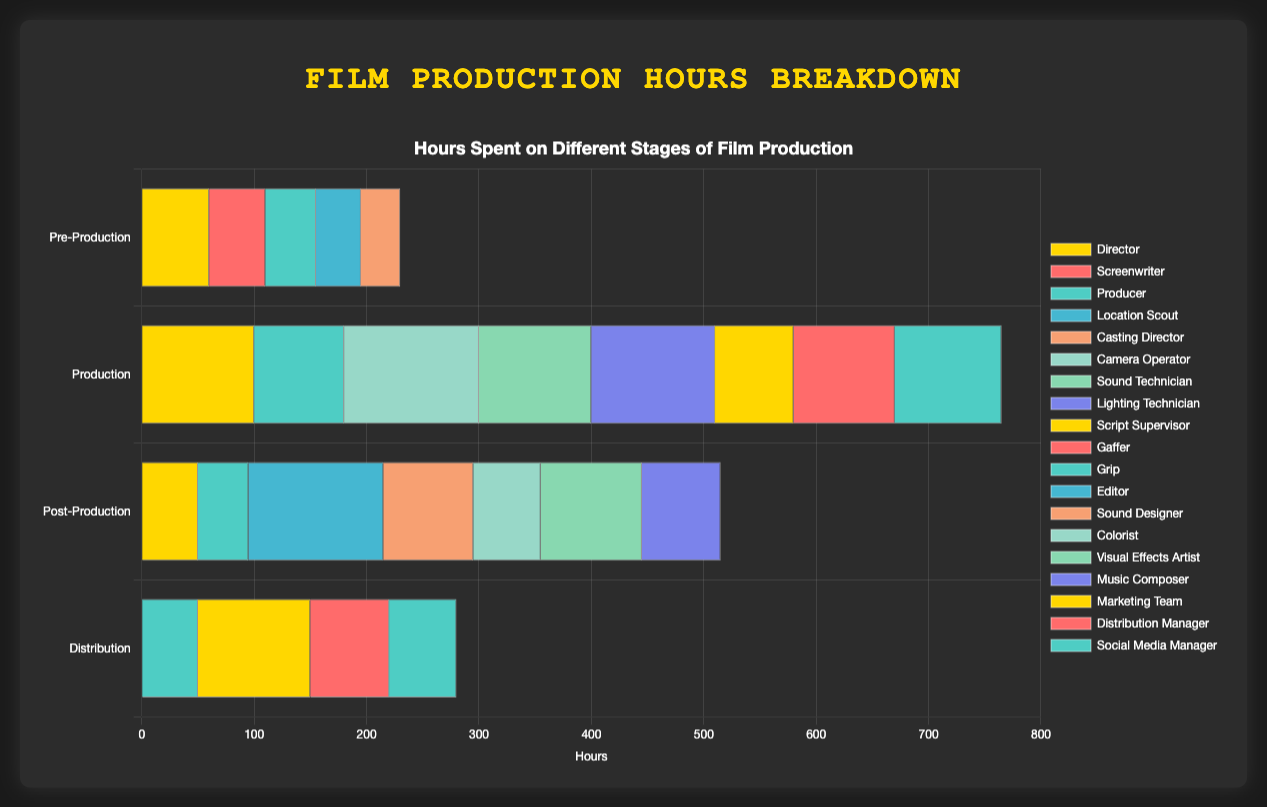Which stage required the most hours for the Director role? The figure shows a horizontal grouped bar chart, where the Director's role is consistently represented with a specific color across all stages. Comparing the lengths of the bars for the Director role, we see that the Production stage has the longest bar for the Director role, indicating 100 hours.
Answer: Production How many total hours did the Producer role spend across all stages? To find the total hours spent by the Producer role, we need to add the hours from each stage: Pre-Production (45), Production (80), Post-Production (45), Distribution (50). The sum is 45 + 80 + 45 + 50.
Answer: 220 Which role had the highest number of hours during the Post-Production stage? In the Post-Production stage, we compare the lengths of the bars for each role. The Editor role has the longest bar, indicating 120 hours, which is the highest value for that stage.
Answer: Editor What is the difference in hours between the Camera Operator and the Gaffer roles during the Production stage? For the Camera Operator in the Production stage, the hours are 120. For the Gaffer, the hours are 90. The difference is calculated as 120 - 90.
Answer: 30 In which stage did the Marketing Team work, and how many hours did they spend? The Marketing Team role only appears in the Distribution stage. By identifying the bar associated with the Marketing Team in this stage, we see they spent 100 hours.
Answer: Distribution, 100 Compare the total hours spent by the Director role and the Editor role across all stages. Which role spent more time? First, we sum up the Director's hours across stages: 60 (Pre-Production) + 100 (Production) + 50 (Post-Production) = 210 hours. Then, we sum the Editor's hours: Post-Production 120 hours. Comparing 210 hours (Director) with 120 hours (Editor), the Director spent more time.
Answer: Director What is the average number of hours worked by the Sound Technician during the Production stage and the Sound Designer during the Post-Production stage? The Sound Technician worked 100 hours during the Production stage. The Sound Designer worked 80 hours during the Post-Production stage. The average is calculated as (100 + 80) / 2 = 90.
Answer: 90 Which role spent more hours in total in the Production stage: Script Supervisor or Grip? For the Production stage, the Script Supervisor role has 70 hours, and the Grip role has 95 hours. Comparing these two values, the Grip role spent more time.
Answer: Grip What is the sum of hours spent by the Location Scout and Casting Director roles in the Pre-Production stage? In the Pre-Production stage, the Location Scout spent 40 hours, and the Casting Director spent 35 hours. Summing these values: 40 + 35 = 75.
Answer: 75 